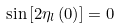Convert formula to latex. <formula><loc_0><loc_0><loc_500><loc_500>\sin \left [ 2 \eta _ { l } \left ( 0 \right ) \right ] = 0</formula> 